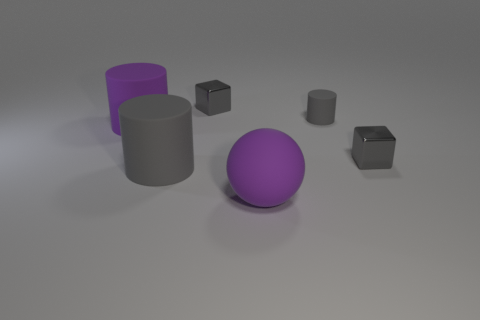There is a big purple matte object behind the ball; what shape is it?
Give a very brief answer. Cylinder. There is a large thing that is the same color as the tiny rubber cylinder; what shape is it?
Provide a succinct answer. Cylinder. What number of gray metallic cubes are the same size as the purple matte sphere?
Your response must be concise. 0. What is the color of the large sphere?
Provide a short and direct response. Purple. There is a small cylinder; is its color the same as the cube in front of the tiny gray rubber cylinder?
Offer a terse response. Yes. What is the size of the sphere that is made of the same material as the tiny cylinder?
Your response must be concise. Large. Is there a metal block that has the same color as the small cylinder?
Offer a terse response. Yes. How many objects are either rubber things on the right side of the purple rubber ball or big purple things?
Your answer should be compact. 3. Does the tiny cylinder have the same material as the object that is on the left side of the large gray rubber cylinder?
Keep it short and to the point. Yes. The matte cylinder that is the same color as the sphere is what size?
Your answer should be compact. Large. 